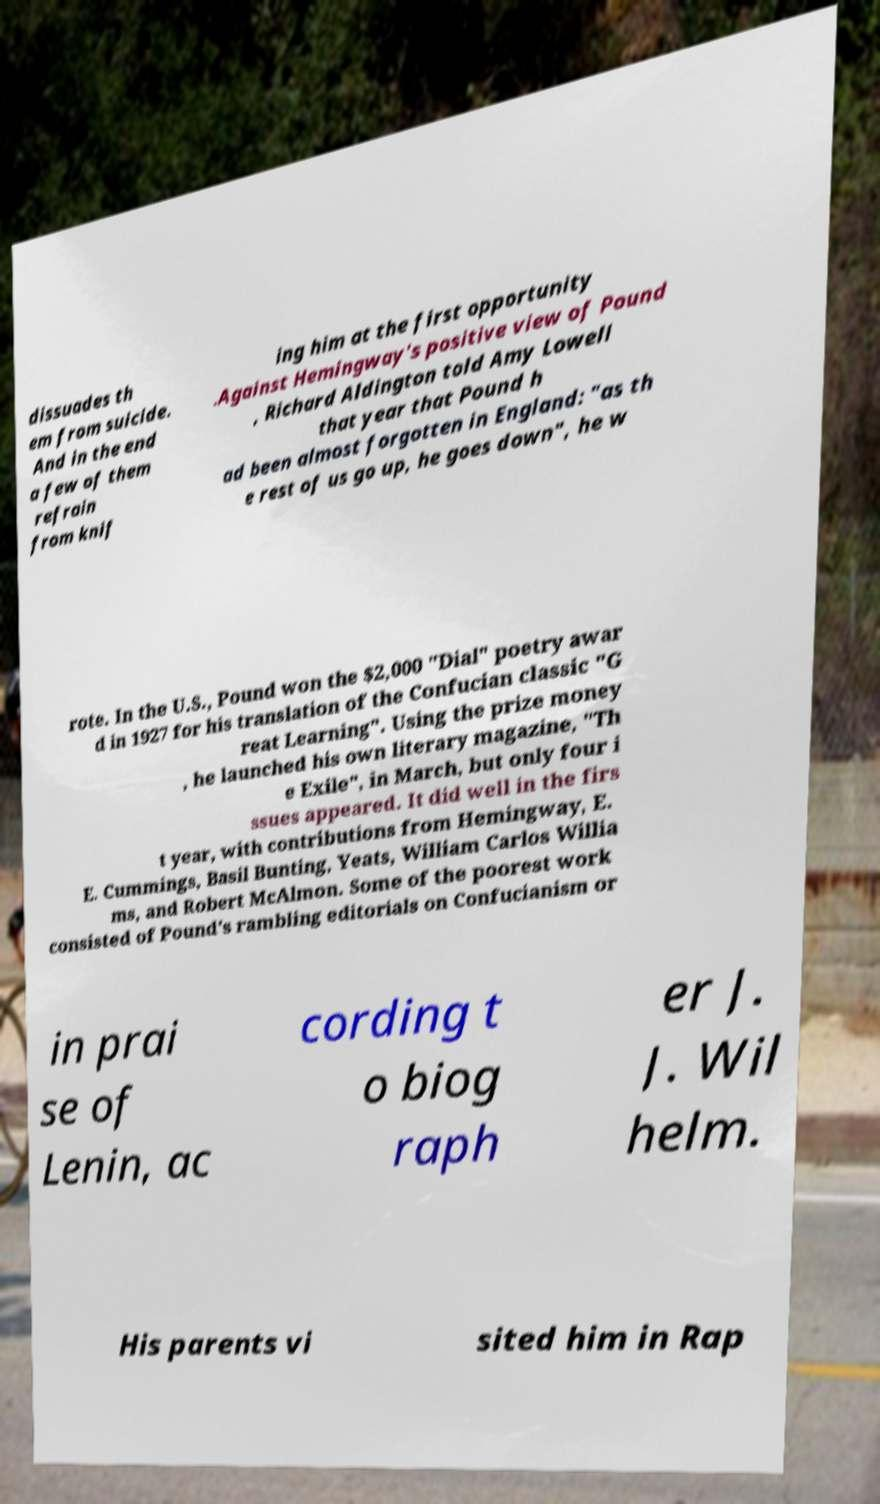What messages or text are displayed in this image? I need them in a readable, typed format. dissuades th em from suicide. And in the end a few of them refrain from knif ing him at the first opportunity .Against Hemingway's positive view of Pound , Richard Aldington told Amy Lowell that year that Pound h ad been almost forgotten in England: "as th e rest of us go up, he goes down", he w rote. In the U.S., Pound won the $2,000 "Dial" poetry awar d in 1927 for his translation of the Confucian classic "G reat Learning". Using the prize money , he launched his own literary magazine, "Th e Exile", in March, but only four i ssues appeared. It did well in the firs t year, with contributions from Hemingway, E. E. Cummings, Basil Bunting, Yeats, William Carlos Willia ms, and Robert McAlmon. Some of the poorest work consisted of Pound's rambling editorials on Confucianism or in prai se of Lenin, ac cording t o biog raph er J. J. Wil helm. His parents vi sited him in Rap 